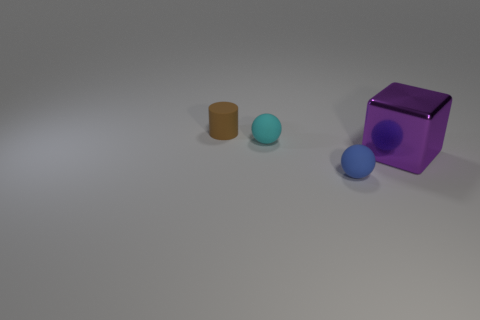Subtract all blocks. How many objects are left? 3 Add 2 blue matte balls. How many objects exist? 6 Subtract 1 balls. How many balls are left? 1 Subtract all cyan spheres. Subtract all cyan cubes. How many spheres are left? 1 Subtract all green spheres. How many yellow blocks are left? 0 Subtract all brown metallic things. Subtract all small matte balls. How many objects are left? 2 Add 4 purple metal cubes. How many purple metal cubes are left? 5 Add 4 blue metal spheres. How many blue metal spheres exist? 4 Subtract 1 brown cylinders. How many objects are left? 3 